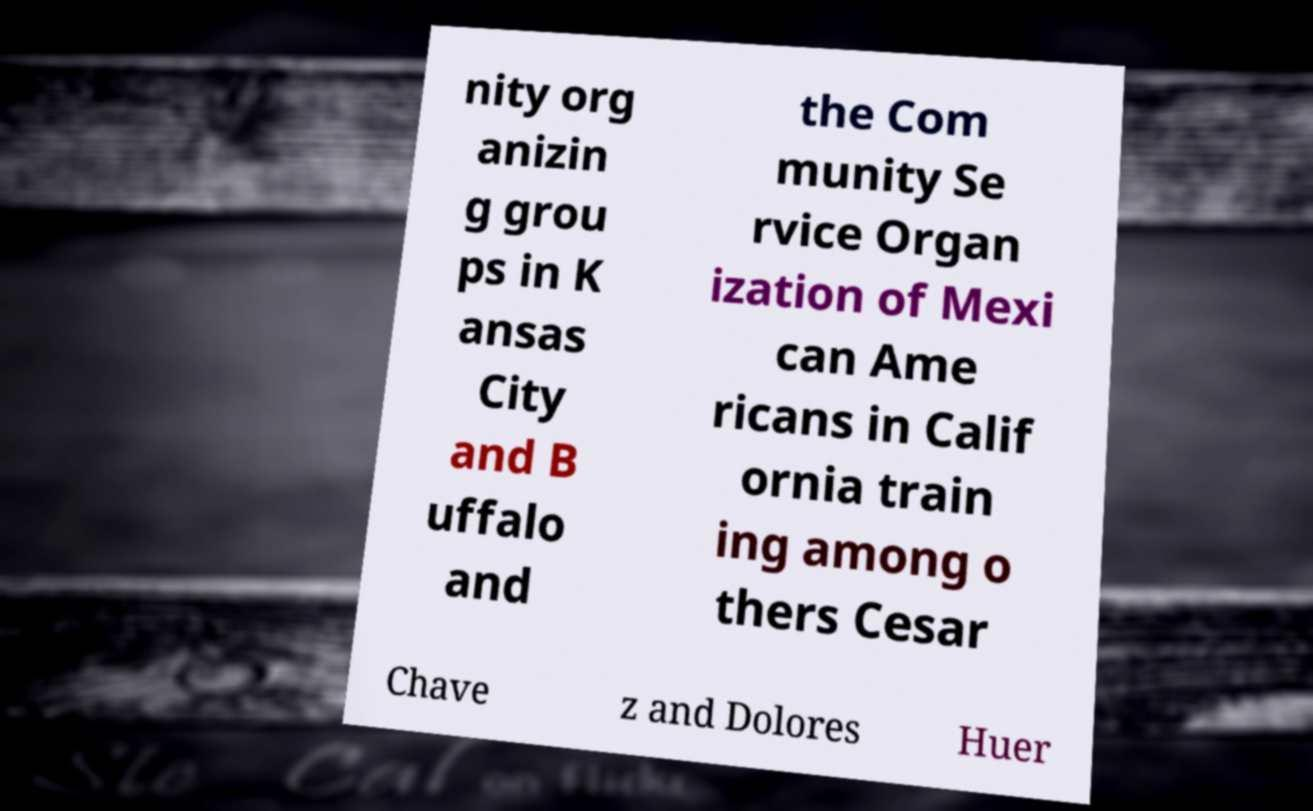Please read and relay the text visible in this image. What does it say? nity org anizin g grou ps in K ansas City and B uffalo and the Com munity Se rvice Organ ization of Mexi can Ame ricans in Calif ornia train ing among o thers Cesar Chave z and Dolores Huer 